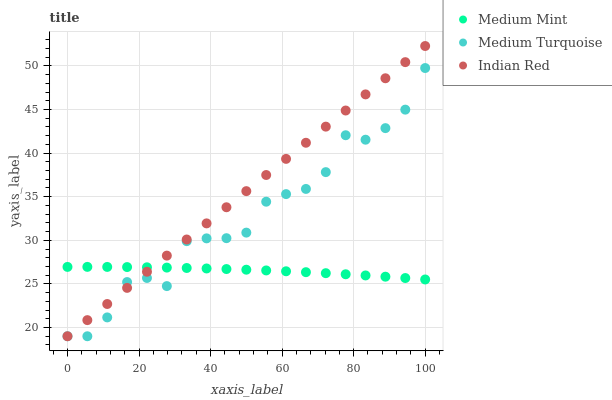Does Medium Mint have the minimum area under the curve?
Answer yes or no. Yes. Does Indian Red have the maximum area under the curve?
Answer yes or no. Yes. Does Medium Turquoise have the minimum area under the curve?
Answer yes or no. No. Does Medium Turquoise have the maximum area under the curve?
Answer yes or no. No. Is Indian Red the smoothest?
Answer yes or no. Yes. Is Medium Turquoise the roughest?
Answer yes or no. Yes. Is Medium Turquoise the smoothest?
Answer yes or no. No. Is Indian Red the roughest?
Answer yes or no. No. Does Indian Red have the lowest value?
Answer yes or no. Yes. Does Indian Red have the highest value?
Answer yes or no. Yes. Does Medium Turquoise have the highest value?
Answer yes or no. No. Does Medium Mint intersect Indian Red?
Answer yes or no. Yes. Is Medium Mint less than Indian Red?
Answer yes or no. No. Is Medium Mint greater than Indian Red?
Answer yes or no. No. 